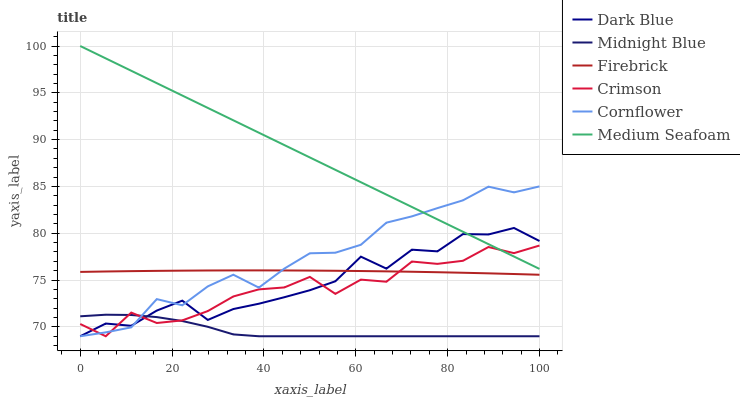Does Midnight Blue have the minimum area under the curve?
Answer yes or no. Yes. Does Medium Seafoam have the maximum area under the curve?
Answer yes or no. Yes. Does Firebrick have the minimum area under the curve?
Answer yes or no. No. Does Firebrick have the maximum area under the curve?
Answer yes or no. No. Is Medium Seafoam the smoothest?
Answer yes or no. Yes. Is Crimson the roughest?
Answer yes or no. Yes. Is Midnight Blue the smoothest?
Answer yes or no. No. Is Midnight Blue the roughest?
Answer yes or no. No. Does Cornflower have the lowest value?
Answer yes or no. Yes. Does Firebrick have the lowest value?
Answer yes or no. No. Does Medium Seafoam have the highest value?
Answer yes or no. Yes. Does Firebrick have the highest value?
Answer yes or no. No. Is Midnight Blue less than Firebrick?
Answer yes or no. Yes. Is Medium Seafoam greater than Midnight Blue?
Answer yes or no. Yes. Does Crimson intersect Dark Blue?
Answer yes or no. Yes. Is Crimson less than Dark Blue?
Answer yes or no. No. Is Crimson greater than Dark Blue?
Answer yes or no. No. Does Midnight Blue intersect Firebrick?
Answer yes or no. No. 